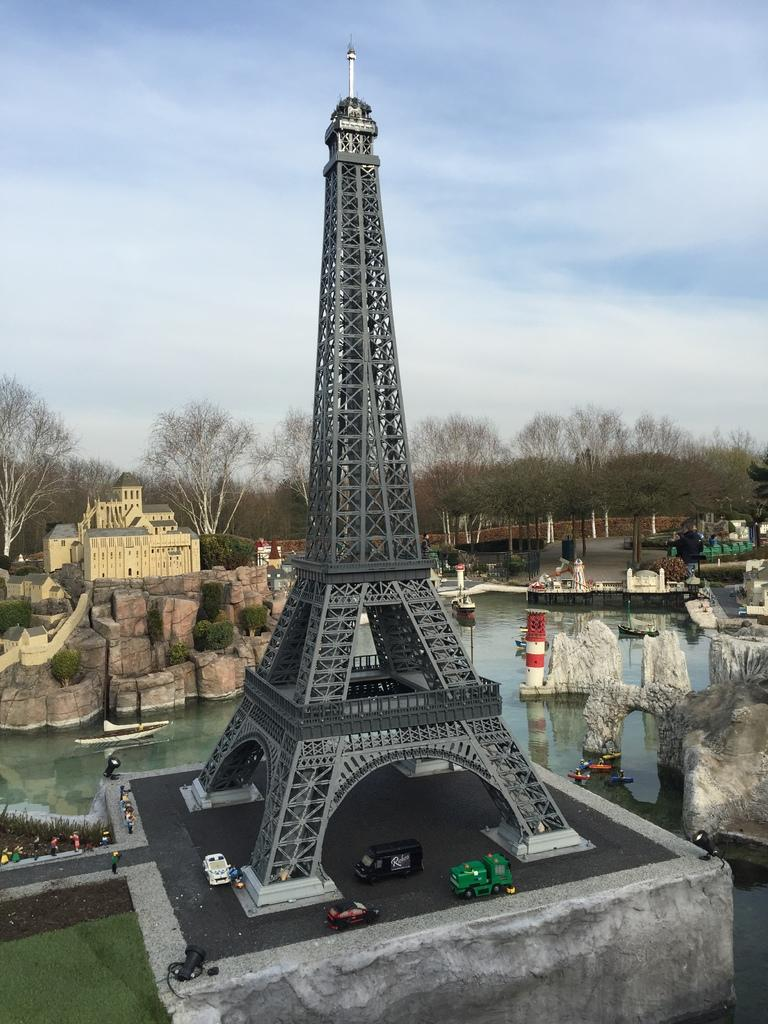What shape is in the middle of the image? The image has a shape resembling the Eiffel Tower in the middle. What can be seen besides the Eiffel Tower shape? There is water visible in the image. What type of natural environment is visible in the background? Trees are present in the background of the image. How would you describe the weather in the image? The sky is sunny at the top of the image, suggesting a clear and sunny day. What sign is the stranger holding in the image? There is no stranger or sign present in the image. 